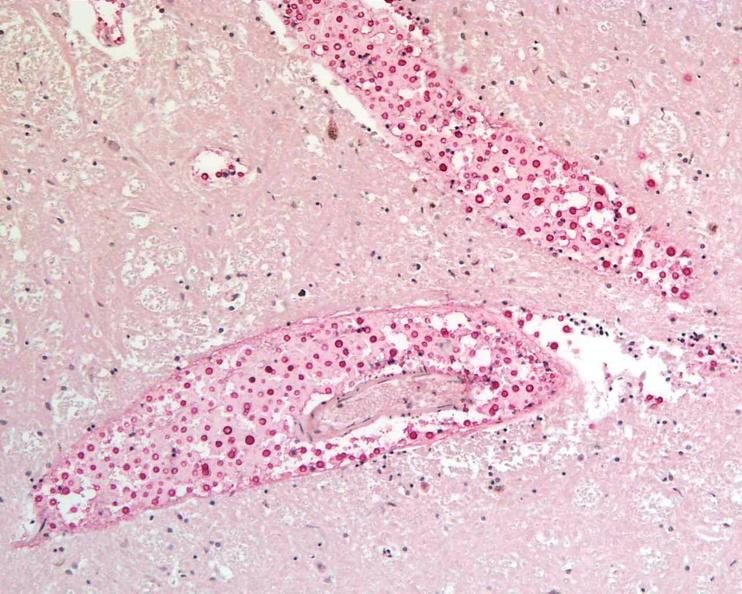what stain?
Answer the question using a single word or phrase. Mucicarmine 